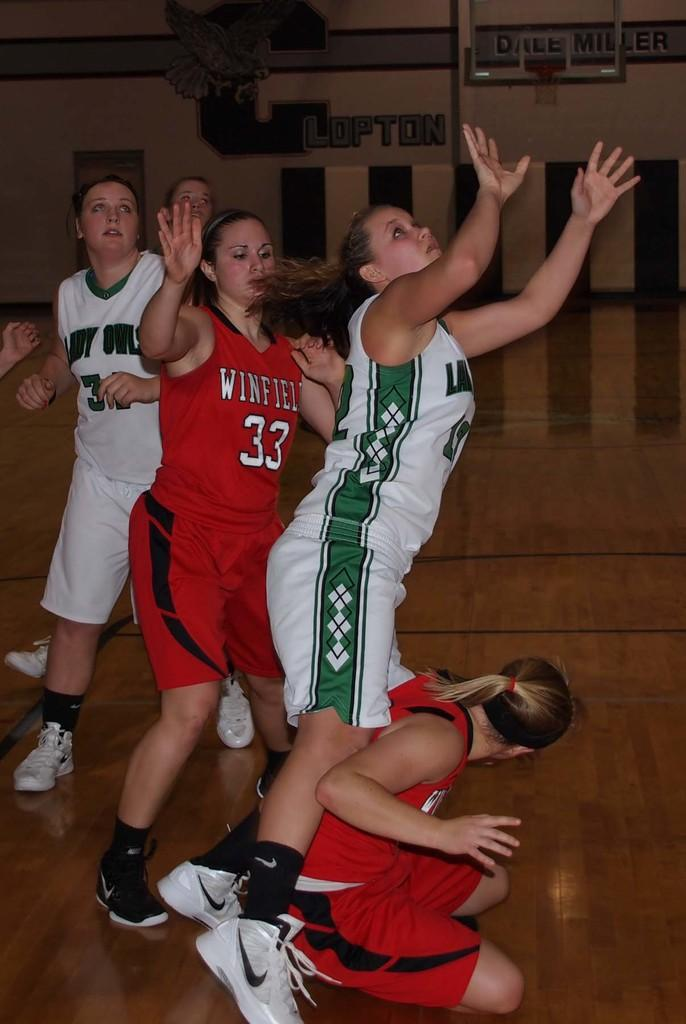Provide a one-sentence caption for the provided image. Winfield are playing volley ball against the owls. 